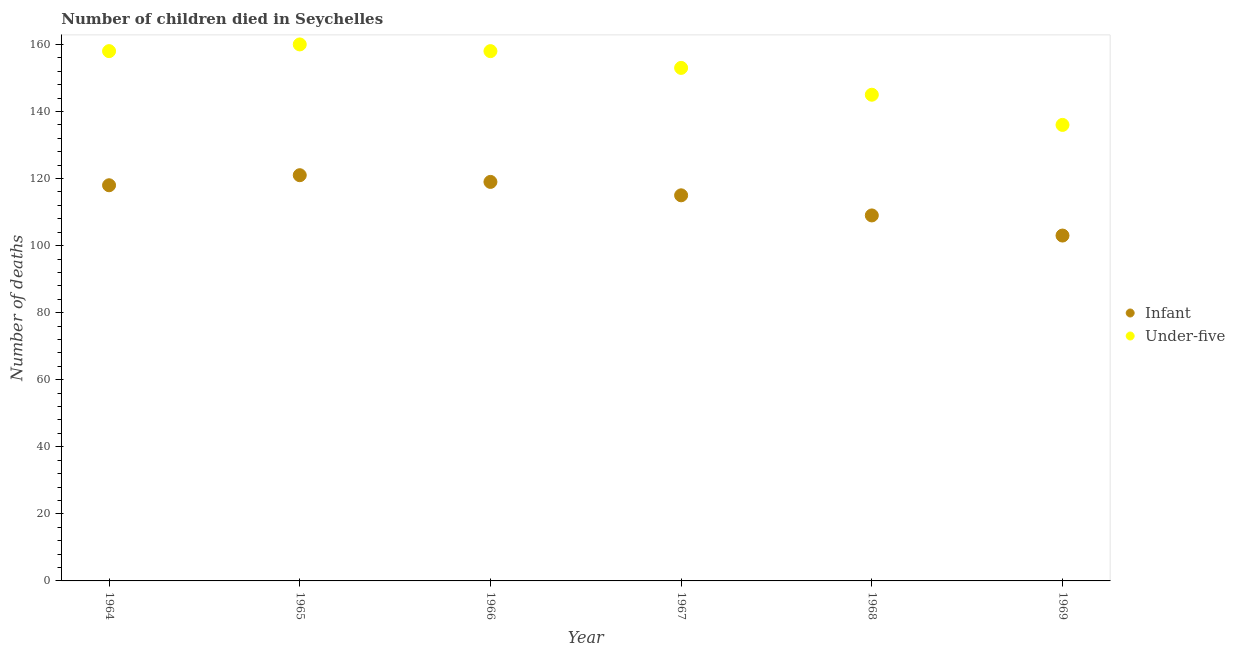Is the number of dotlines equal to the number of legend labels?
Ensure brevity in your answer.  Yes. What is the number of infant deaths in 1969?
Give a very brief answer. 103. Across all years, what is the maximum number of under-five deaths?
Make the answer very short. 160. Across all years, what is the minimum number of under-five deaths?
Your response must be concise. 136. In which year was the number of under-five deaths maximum?
Keep it short and to the point. 1965. In which year was the number of infant deaths minimum?
Make the answer very short. 1969. What is the total number of under-five deaths in the graph?
Offer a terse response. 910. What is the difference between the number of under-five deaths in 1965 and that in 1968?
Offer a terse response. 15. What is the difference between the number of under-five deaths in 1966 and the number of infant deaths in 1968?
Your answer should be compact. 49. What is the average number of under-five deaths per year?
Your answer should be compact. 151.67. In the year 1969, what is the difference between the number of under-five deaths and number of infant deaths?
Offer a very short reply. 33. In how many years, is the number of under-five deaths greater than 100?
Your answer should be very brief. 6. What is the ratio of the number of infant deaths in 1966 to that in 1968?
Your answer should be compact. 1.09. What is the difference between the highest and the lowest number of infant deaths?
Your answer should be very brief. 18. Is the sum of the number of infant deaths in 1964 and 1968 greater than the maximum number of under-five deaths across all years?
Ensure brevity in your answer.  Yes. Does the number of under-five deaths monotonically increase over the years?
Give a very brief answer. No. How many years are there in the graph?
Keep it short and to the point. 6. What is the difference between two consecutive major ticks on the Y-axis?
Make the answer very short. 20. Does the graph contain any zero values?
Provide a succinct answer. No. Does the graph contain grids?
Provide a succinct answer. No. How many legend labels are there?
Make the answer very short. 2. How are the legend labels stacked?
Offer a very short reply. Vertical. What is the title of the graph?
Make the answer very short. Number of children died in Seychelles. Does "Urban" appear as one of the legend labels in the graph?
Offer a terse response. No. What is the label or title of the X-axis?
Provide a succinct answer. Year. What is the label or title of the Y-axis?
Make the answer very short. Number of deaths. What is the Number of deaths in Infant in 1964?
Your answer should be very brief. 118. What is the Number of deaths of Under-five in 1964?
Provide a succinct answer. 158. What is the Number of deaths in Infant in 1965?
Your response must be concise. 121. What is the Number of deaths of Under-five in 1965?
Ensure brevity in your answer.  160. What is the Number of deaths in Infant in 1966?
Your response must be concise. 119. What is the Number of deaths in Under-five in 1966?
Offer a very short reply. 158. What is the Number of deaths of Infant in 1967?
Ensure brevity in your answer.  115. What is the Number of deaths in Under-five in 1967?
Your answer should be very brief. 153. What is the Number of deaths of Infant in 1968?
Offer a very short reply. 109. What is the Number of deaths in Under-five in 1968?
Provide a succinct answer. 145. What is the Number of deaths of Infant in 1969?
Offer a terse response. 103. What is the Number of deaths of Under-five in 1969?
Your answer should be very brief. 136. Across all years, what is the maximum Number of deaths of Infant?
Your response must be concise. 121. Across all years, what is the maximum Number of deaths in Under-five?
Make the answer very short. 160. Across all years, what is the minimum Number of deaths of Infant?
Make the answer very short. 103. Across all years, what is the minimum Number of deaths in Under-five?
Make the answer very short. 136. What is the total Number of deaths in Infant in the graph?
Ensure brevity in your answer.  685. What is the total Number of deaths in Under-five in the graph?
Your response must be concise. 910. What is the difference between the Number of deaths in Under-five in 1964 and that in 1967?
Your answer should be very brief. 5. What is the difference between the Number of deaths in Infant in 1964 and that in 1968?
Give a very brief answer. 9. What is the difference between the Number of deaths in Under-five in 1964 and that in 1968?
Make the answer very short. 13. What is the difference between the Number of deaths of Infant in 1964 and that in 1969?
Your answer should be compact. 15. What is the difference between the Number of deaths in Under-five in 1964 and that in 1969?
Your answer should be very brief. 22. What is the difference between the Number of deaths of Under-five in 1965 and that in 1966?
Your answer should be very brief. 2. What is the difference between the Number of deaths in Under-five in 1965 and that in 1969?
Keep it short and to the point. 24. What is the difference between the Number of deaths in Infant in 1966 and that in 1967?
Offer a very short reply. 4. What is the difference between the Number of deaths of Under-five in 1966 and that in 1968?
Your answer should be very brief. 13. What is the difference between the Number of deaths of Infant in 1966 and that in 1969?
Make the answer very short. 16. What is the difference between the Number of deaths of Infant in 1967 and that in 1969?
Ensure brevity in your answer.  12. What is the difference between the Number of deaths of Under-five in 1967 and that in 1969?
Make the answer very short. 17. What is the difference between the Number of deaths in Infant in 1964 and the Number of deaths in Under-five in 1965?
Offer a very short reply. -42. What is the difference between the Number of deaths in Infant in 1964 and the Number of deaths in Under-five in 1967?
Your answer should be compact. -35. What is the difference between the Number of deaths of Infant in 1965 and the Number of deaths of Under-five in 1966?
Provide a short and direct response. -37. What is the difference between the Number of deaths in Infant in 1965 and the Number of deaths in Under-five in 1967?
Your answer should be very brief. -32. What is the difference between the Number of deaths in Infant in 1965 and the Number of deaths in Under-five in 1968?
Keep it short and to the point. -24. What is the difference between the Number of deaths in Infant in 1966 and the Number of deaths in Under-five in 1967?
Your answer should be very brief. -34. What is the difference between the Number of deaths in Infant in 1966 and the Number of deaths in Under-five in 1968?
Offer a terse response. -26. What is the difference between the Number of deaths of Infant in 1967 and the Number of deaths of Under-five in 1968?
Offer a terse response. -30. What is the difference between the Number of deaths in Infant in 1968 and the Number of deaths in Under-five in 1969?
Offer a terse response. -27. What is the average Number of deaths of Infant per year?
Offer a terse response. 114.17. What is the average Number of deaths in Under-five per year?
Offer a terse response. 151.67. In the year 1965, what is the difference between the Number of deaths of Infant and Number of deaths of Under-five?
Your answer should be very brief. -39. In the year 1966, what is the difference between the Number of deaths in Infant and Number of deaths in Under-five?
Your answer should be compact. -39. In the year 1967, what is the difference between the Number of deaths of Infant and Number of deaths of Under-five?
Ensure brevity in your answer.  -38. In the year 1968, what is the difference between the Number of deaths in Infant and Number of deaths in Under-five?
Provide a succinct answer. -36. In the year 1969, what is the difference between the Number of deaths in Infant and Number of deaths in Under-five?
Offer a very short reply. -33. What is the ratio of the Number of deaths in Infant in 1964 to that in 1965?
Provide a succinct answer. 0.98. What is the ratio of the Number of deaths of Under-five in 1964 to that in 1965?
Offer a very short reply. 0.99. What is the ratio of the Number of deaths in Infant in 1964 to that in 1966?
Offer a terse response. 0.99. What is the ratio of the Number of deaths in Infant in 1964 to that in 1967?
Offer a terse response. 1.03. What is the ratio of the Number of deaths in Under-five in 1964 to that in 1967?
Offer a very short reply. 1.03. What is the ratio of the Number of deaths of Infant in 1964 to that in 1968?
Provide a succinct answer. 1.08. What is the ratio of the Number of deaths in Under-five in 1964 to that in 1968?
Your response must be concise. 1.09. What is the ratio of the Number of deaths of Infant in 1964 to that in 1969?
Offer a terse response. 1.15. What is the ratio of the Number of deaths of Under-five in 1964 to that in 1969?
Offer a very short reply. 1.16. What is the ratio of the Number of deaths in Infant in 1965 to that in 1966?
Give a very brief answer. 1.02. What is the ratio of the Number of deaths in Under-five in 1965 to that in 1966?
Your response must be concise. 1.01. What is the ratio of the Number of deaths of Infant in 1965 to that in 1967?
Give a very brief answer. 1.05. What is the ratio of the Number of deaths in Under-five in 1965 to that in 1967?
Give a very brief answer. 1.05. What is the ratio of the Number of deaths of Infant in 1965 to that in 1968?
Give a very brief answer. 1.11. What is the ratio of the Number of deaths in Under-five in 1965 to that in 1968?
Provide a short and direct response. 1.1. What is the ratio of the Number of deaths in Infant in 1965 to that in 1969?
Provide a short and direct response. 1.17. What is the ratio of the Number of deaths of Under-five in 1965 to that in 1969?
Provide a succinct answer. 1.18. What is the ratio of the Number of deaths in Infant in 1966 to that in 1967?
Keep it short and to the point. 1.03. What is the ratio of the Number of deaths in Under-five in 1966 to that in 1967?
Offer a very short reply. 1.03. What is the ratio of the Number of deaths of Infant in 1966 to that in 1968?
Provide a short and direct response. 1.09. What is the ratio of the Number of deaths in Under-five in 1966 to that in 1968?
Your answer should be compact. 1.09. What is the ratio of the Number of deaths in Infant in 1966 to that in 1969?
Your response must be concise. 1.16. What is the ratio of the Number of deaths in Under-five in 1966 to that in 1969?
Your response must be concise. 1.16. What is the ratio of the Number of deaths of Infant in 1967 to that in 1968?
Offer a very short reply. 1.05. What is the ratio of the Number of deaths of Under-five in 1967 to that in 1968?
Your response must be concise. 1.06. What is the ratio of the Number of deaths in Infant in 1967 to that in 1969?
Keep it short and to the point. 1.12. What is the ratio of the Number of deaths in Under-five in 1967 to that in 1969?
Your answer should be compact. 1.12. What is the ratio of the Number of deaths in Infant in 1968 to that in 1969?
Provide a short and direct response. 1.06. What is the ratio of the Number of deaths in Under-five in 1968 to that in 1969?
Ensure brevity in your answer.  1.07. What is the difference between the highest and the second highest Number of deaths in Infant?
Give a very brief answer. 2. What is the difference between the highest and the lowest Number of deaths in Infant?
Your answer should be compact. 18. 